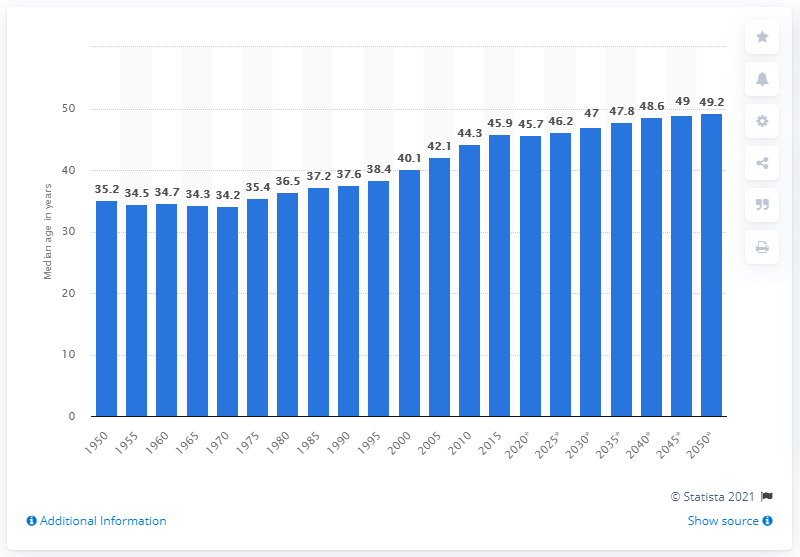Give some essential details in this illustration. The median age of Germans in 2050 is projected to be 49.2 years old. 